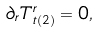<formula> <loc_0><loc_0><loc_500><loc_500>\partial _ { r } T ^ { r } _ { t ( 2 ) } = 0 ,</formula> 